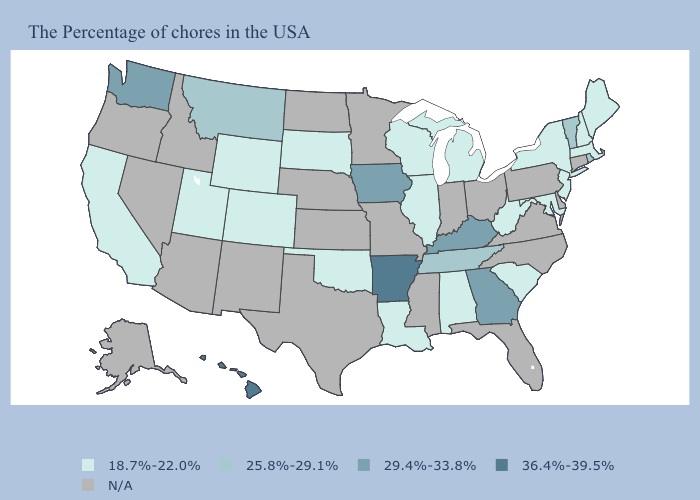Does New York have the highest value in the Northeast?
Quick response, please. No. Name the states that have a value in the range 25.8%-29.1%?
Answer briefly. Rhode Island, Vermont, Tennessee, Montana. Which states have the lowest value in the South?
Give a very brief answer. Maryland, South Carolina, West Virginia, Alabama, Louisiana, Oklahoma. What is the lowest value in the USA?
Be succinct. 18.7%-22.0%. Does the map have missing data?
Quick response, please. Yes. Name the states that have a value in the range 36.4%-39.5%?
Keep it brief. Arkansas, Hawaii. Among the states that border Texas , does Louisiana have the highest value?
Give a very brief answer. No. What is the value of Alabama?
Short answer required. 18.7%-22.0%. Among the states that border Michigan , which have the lowest value?
Quick response, please. Wisconsin. Among the states that border Florida , does Alabama have the highest value?
Write a very short answer. No. Which states hav the highest value in the Northeast?
Answer briefly. Rhode Island, Vermont. What is the highest value in the Northeast ?
Quick response, please. 25.8%-29.1%. What is the value of Arkansas?
Keep it brief. 36.4%-39.5%. What is the value of New York?
Short answer required. 18.7%-22.0%. Does Iowa have the highest value in the MidWest?
Be succinct. Yes. 